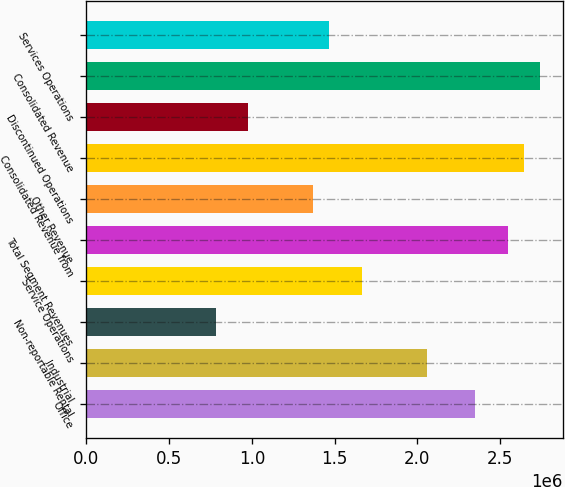Convert chart. <chart><loc_0><loc_0><loc_500><loc_500><bar_chart><fcel>Office<fcel>Industrial<fcel>Non-reportable Rental<fcel>Service Operations<fcel>Total Segment Revenues<fcel>Other Revenue<fcel>Consolidated Revenue from<fcel>Discontinued Operations<fcel>Consolidated Revenue<fcel>Services Operations<nl><fcel>2.34852e+06<fcel>2.055e+06<fcel>783115<fcel>1.66365e+06<fcel>2.54419e+06<fcel>1.37014e+06<fcel>2.64203e+06<fcel>978790<fcel>2.73986e+06<fcel>1.46798e+06<nl></chart> 